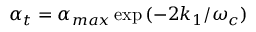<formula> <loc_0><loc_0><loc_500><loc_500>\alpha _ { t } = \alpha _ { \max } \exp { ( - 2 k _ { 1 } / \omega _ { c } ) }</formula> 